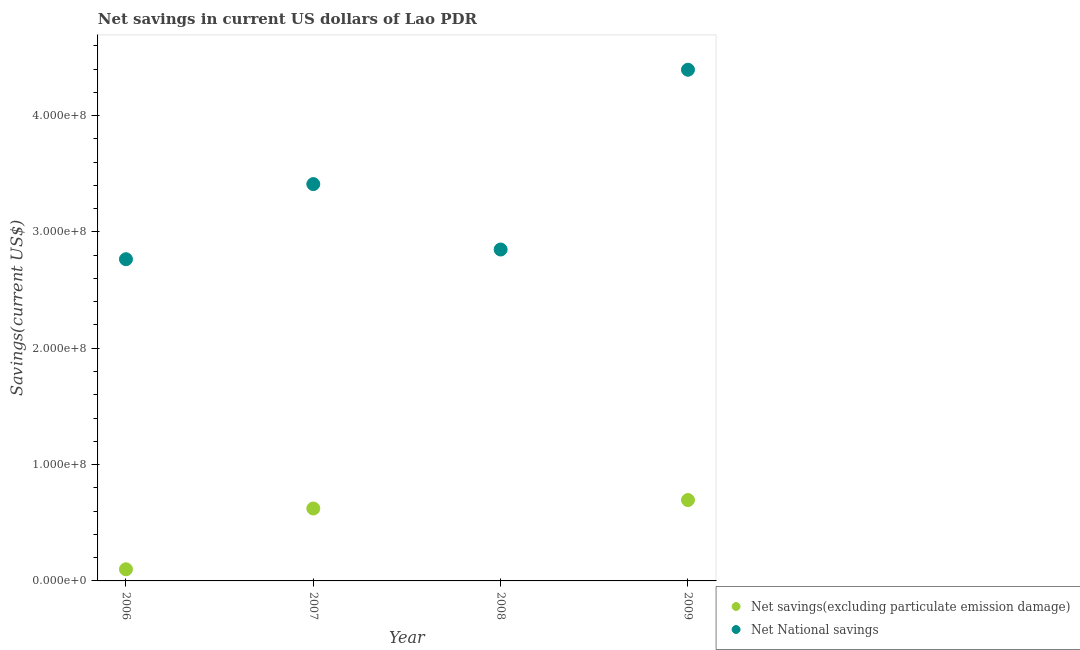Is the number of dotlines equal to the number of legend labels?
Your response must be concise. No. What is the net national savings in 2007?
Offer a very short reply. 3.41e+08. Across all years, what is the maximum net savings(excluding particulate emission damage)?
Your answer should be compact. 6.95e+07. Across all years, what is the minimum net savings(excluding particulate emission damage)?
Provide a short and direct response. 0. What is the total net savings(excluding particulate emission damage) in the graph?
Provide a short and direct response. 1.42e+08. What is the difference between the net national savings in 2006 and that in 2007?
Your answer should be very brief. -6.46e+07. What is the difference between the net national savings in 2007 and the net savings(excluding particulate emission damage) in 2006?
Make the answer very short. 3.31e+08. What is the average net savings(excluding particulate emission damage) per year?
Offer a very short reply. 3.54e+07. In the year 2007, what is the difference between the net national savings and net savings(excluding particulate emission damage)?
Provide a succinct answer. 2.79e+08. What is the ratio of the net savings(excluding particulate emission damage) in 2006 to that in 2007?
Make the answer very short. 0.16. Is the net national savings in 2008 less than that in 2009?
Offer a terse response. Yes. Is the difference between the net savings(excluding particulate emission damage) in 2006 and 2009 greater than the difference between the net national savings in 2006 and 2009?
Keep it short and to the point. Yes. What is the difference between the highest and the second highest net savings(excluding particulate emission damage)?
Make the answer very short. 7.26e+06. What is the difference between the highest and the lowest net national savings?
Your answer should be compact. 1.63e+08. In how many years, is the net national savings greater than the average net national savings taken over all years?
Offer a terse response. 2. Is the sum of the net savings(excluding particulate emission damage) in 2006 and 2009 greater than the maximum net national savings across all years?
Your response must be concise. No. Is the net national savings strictly greater than the net savings(excluding particulate emission damage) over the years?
Provide a short and direct response. Yes. How many dotlines are there?
Give a very brief answer. 2. How many years are there in the graph?
Provide a short and direct response. 4. Are the values on the major ticks of Y-axis written in scientific E-notation?
Provide a succinct answer. Yes. Does the graph contain any zero values?
Offer a terse response. Yes. Does the graph contain grids?
Provide a short and direct response. No. How are the legend labels stacked?
Provide a short and direct response. Vertical. What is the title of the graph?
Your response must be concise. Net savings in current US dollars of Lao PDR. What is the label or title of the Y-axis?
Provide a succinct answer. Savings(current US$). What is the Savings(current US$) of Net savings(excluding particulate emission damage) in 2006?
Your response must be concise. 1.00e+07. What is the Savings(current US$) of Net National savings in 2006?
Your response must be concise. 2.77e+08. What is the Savings(current US$) in Net savings(excluding particulate emission damage) in 2007?
Offer a terse response. 6.22e+07. What is the Savings(current US$) in Net National savings in 2007?
Offer a very short reply. 3.41e+08. What is the Savings(current US$) of Net savings(excluding particulate emission damage) in 2008?
Your answer should be very brief. 0. What is the Savings(current US$) in Net National savings in 2008?
Offer a terse response. 2.85e+08. What is the Savings(current US$) of Net savings(excluding particulate emission damage) in 2009?
Keep it short and to the point. 6.95e+07. What is the Savings(current US$) in Net National savings in 2009?
Provide a short and direct response. 4.39e+08. Across all years, what is the maximum Savings(current US$) of Net savings(excluding particulate emission damage)?
Your answer should be compact. 6.95e+07. Across all years, what is the maximum Savings(current US$) of Net National savings?
Provide a succinct answer. 4.39e+08. Across all years, what is the minimum Savings(current US$) in Net National savings?
Your answer should be very brief. 2.77e+08. What is the total Savings(current US$) of Net savings(excluding particulate emission damage) in the graph?
Your answer should be very brief. 1.42e+08. What is the total Savings(current US$) of Net National savings in the graph?
Make the answer very short. 1.34e+09. What is the difference between the Savings(current US$) of Net savings(excluding particulate emission damage) in 2006 and that in 2007?
Your response must be concise. -5.22e+07. What is the difference between the Savings(current US$) of Net National savings in 2006 and that in 2007?
Give a very brief answer. -6.46e+07. What is the difference between the Savings(current US$) of Net National savings in 2006 and that in 2008?
Make the answer very short. -8.35e+06. What is the difference between the Savings(current US$) in Net savings(excluding particulate emission damage) in 2006 and that in 2009?
Your answer should be very brief. -5.95e+07. What is the difference between the Savings(current US$) in Net National savings in 2006 and that in 2009?
Provide a succinct answer. -1.63e+08. What is the difference between the Savings(current US$) in Net National savings in 2007 and that in 2008?
Keep it short and to the point. 5.62e+07. What is the difference between the Savings(current US$) of Net savings(excluding particulate emission damage) in 2007 and that in 2009?
Your response must be concise. -7.26e+06. What is the difference between the Savings(current US$) in Net National savings in 2007 and that in 2009?
Your response must be concise. -9.83e+07. What is the difference between the Savings(current US$) in Net National savings in 2008 and that in 2009?
Give a very brief answer. -1.55e+08. What is the difference between the Savings(current US$) in Net savings(excluding particulate emission damage) in 2006 and the Savings(current US$) in Net National savings in 2007?
Make the answer very short. -3.31e+08. What is the difference between the Savings(current US$) in Net savings(excluding particulate emission damage) in 2006 and the Savings(current US$) in Net National savings in 2008?
Make the answer very short. -2.75e+08. What is the difference between the Savings(current US$) of Net savings(excluding particulate emission damage) in 2006 and the Savings(current US$) of Net National savings in 2009?
Give a very brief answer. -4.29e+08. What is the difference between the Savings(current US$) in Net savings(excluding particulate emission damage) in 2007 and the Savings(current US$) in Net National savings in 2008?
Ensure brevity in your answer.  -2.23e+08. What is the difference between the Savings(current US$) in Net savings(excluding particulate emission damage) in 2007 and the Savings(current US$) in Net National savings in 2009?
Your response must be concise. -3.77e+08. What is the average Savings(current US$) in Net savings(excluding particulate emission damage) per year?
Ensure brevity in your answer.  3.54e+07. What is the average Savings(current US$) in Net National savings per year?
Your response must be concise. 3.35e+08. In the year 2006, what is the difference between the Savings(current US$) of Net savings(excluding particulate emission damage) and Savings(current US$) of Net National savings?
Make the answer very short. -2.67e+08. In the year 2007, what is the difference between the Savings(current US$) of Net savings(excluding particulate emission damage) and Savings(current US$) of Net National savings?
Offer a terse response. -2.79e+08. In the year 2009, what is the difference between the Savings(current US$) in Net savings(excluding particulate emission damage) and Savings(current US$) in Net National savings?
Provide a succinct answer. -3.70e+08. What is the ratio of the Savings(current US$) in Net savings(excluding particulate emission damage) in 2006 to that in 2007?
Your response must be concise. 0.16. What is the ratio of the Savings(current US$) of Net National savings in 2006 to that in 2007?
Offer a very short reply. 0.81. What is the ratio of the Savings(current US$) in Net National savings in 2006 to that in 2008?
Offer a very short reply. 0.97. What is the ratio of the Savings(current US$) in Net savings(excluding particulate emission damage) in 2006 to that in 2009?
Your response must be concise. 0.14. What is the ratio of the Savings(current US$) in Net National savings in 2006 to that in 2009?
Offer a very short reply. 0.63. What is the ratio of the Savings(current US$) of Net National savings in 2007 to that in 2008?
Provide a short and direct response. 1.2. What is the ratio of the Savings(current US$) in Net savings(excluding particulate emission damage) in 2007 to that in 2009?
Provide a short and direct response. 0.9. What is the ratio of the Savings(current US$) in Net National savings in 2007 to that in 2009?
Provide a short and direct response. 0.78. What is the ratio of the Savings(current US$) of Net National savings in 2008 to that in 2009?
Make the answer very short. 0.65. What is the difference between the highest and the second highest Savings(current US$) of Net savings(excluding particulate emission damage)?
Make the answer very short. 7.26e+06. What is the difference between the highest and the second highest Savings(current US$) of Net National savings?
Your answer should be compact. 9.83e+07. What is the difference between the highest and the lowest Savings(current US$) of Net savings(excluding particulate emission damage)?
Make the answer very short. 6.95e+07. What is the difference between the highest and the lowest Savings(current US$) in Net National savings?
Offer a very short reply. 1.63e+08. 